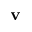<formula> <loc_0><loc_0><loc_500><loc_500>v</formula> 